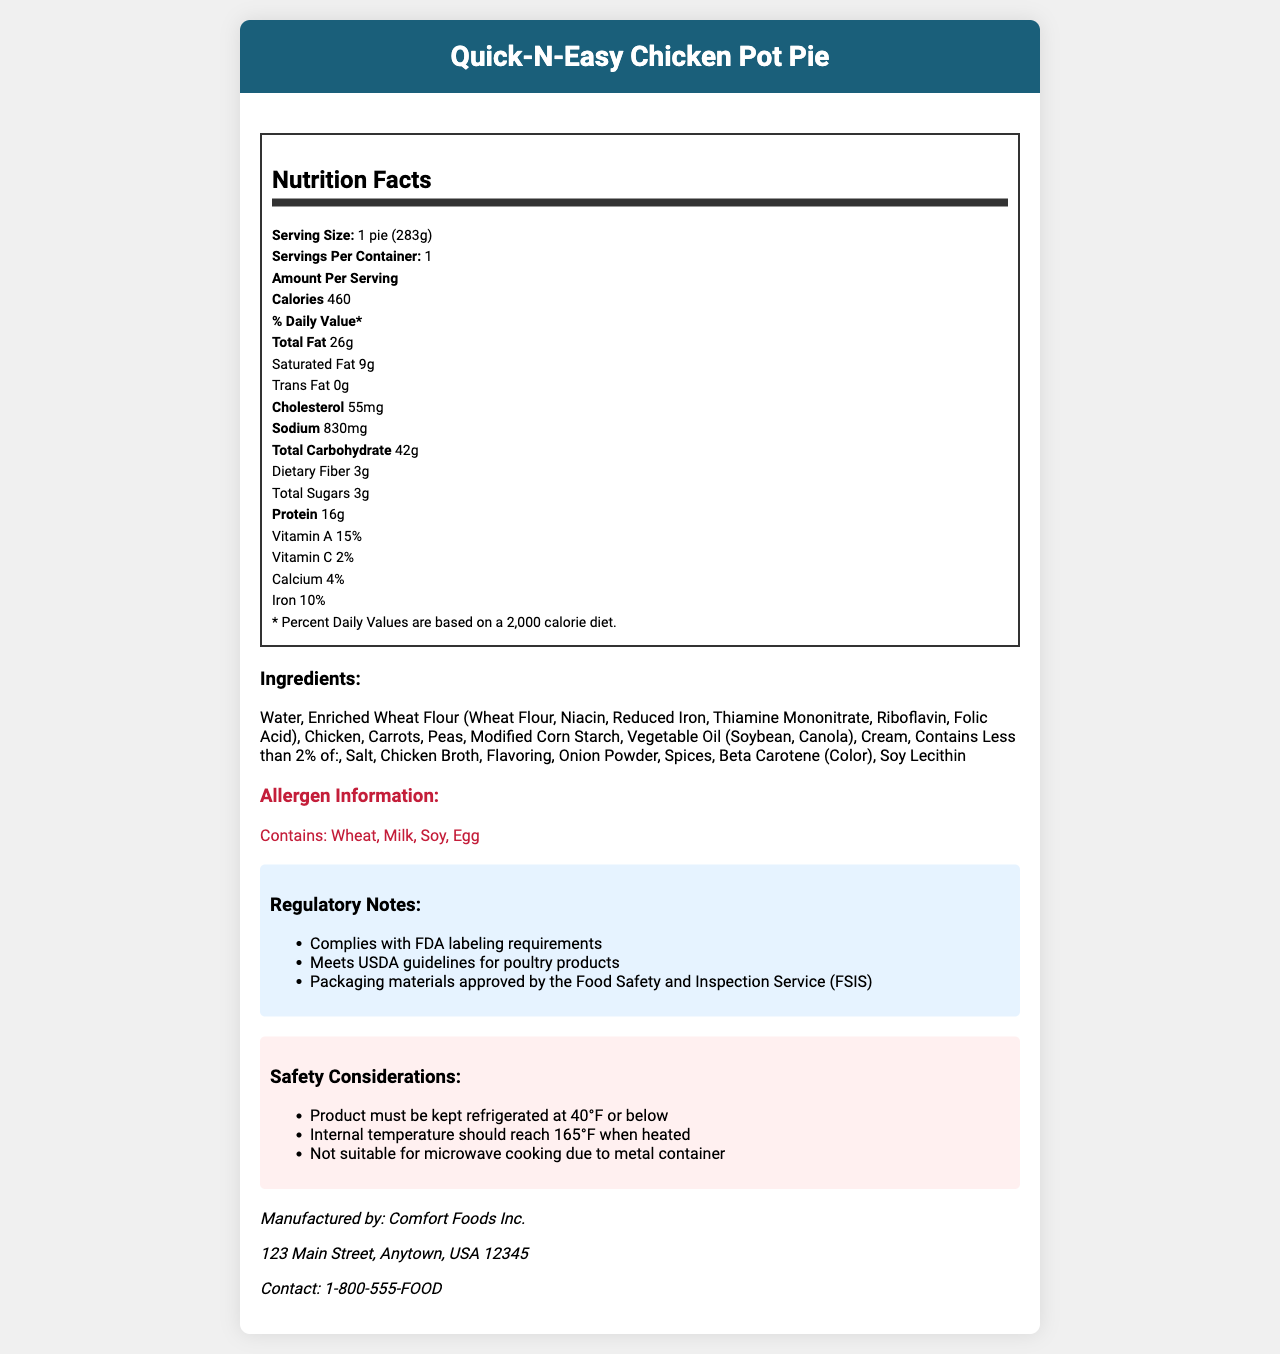what is the product name? The product name is displayed prominently in the header of the document.
Answer: Quick-N-Easy Chicken Pot Pie what is the serving size of the product? The serving size is stated under the Nutrition Facts section as "1 pie (283g)".
Answer: 1 pie (283g) how many allergens are listed and what are they? The allergen information section lists "Contains Wheat, Milk, Soy, Egg".
Answer: Four: Wheat, Milk, Soy, Egg what is the total fat content per serving? The total fat content is listed under the Nutrition Facts section as "Total Fat 26g".
Answer: 26g who is the manufacturer of the product? The manufacturer's name is provided in the Manufacturer Information section.
Answer: Comfort Foods Inc. what is the percentage of Vitamin A per serving? A. 10% B. 15% C. 20% The Nutrition Facts section states that the percentage of Vitamin A per serving is 15%.
Answer: B which ingredient is present in the smallest amount? A. Chicken B. Onion Powder C. Water D. Carrots The ingredient list mentions "Contains Less than 2% of: Salt, Chicken Broth, Flavoring, Onion Powder, Spices, Beta Carotene (Color), Soy Lecithin", indicating Onion Powder is in a minor quantity.
Answer: B is this product safe for people with soy allergies? The allergen information states that the product contains soy.
Answer: No does the product comply with USDA guidelines for poultry products? This information is included in the Regulatory Notes section which states, "Meets USDA guidelines for poultry products".
Answer: Yes summarize the main points regarding the product's regulatory and safety notes. The document lists these points under Regulatory Notes and Safety Considerations, detailing compliance and safety storage and cooking instructions.
Answer: The product complies with FDA labeling requirements and meets USDA guidelines for poultry products. Its packaging materials are approved by the FSIS. It must be kept refrigerated at 40°F or below, and its internal temperature should reach 165°F when heated. It is not suitable for microwave cooking due to the metal container. what is the internal heating temperature requirement for the product? The Safety Considerations section clarifies that the internal temperature should reach 165°F when heated.
Answer: 165°F does the product contain iron? If so, what is the percentage of the daily value? Under the Nutrition Facts, iron content per serving is listed as 10% of the daily value.
Answer: Yes, 10% is the product suitable for microwave cooking? The Safety Considerations section explicitly states it's not suitable for microwave cooking due to the metal container.
Answer: No what is the address of the manufacturer? The address is listed in the Manufacturer Information section.
Answer: 123 Main Street, Anytown, USA 12345 when was the last product recall? Under Recall History, it's stated that the last recall date is "None", and recall reason is "N/A".
Answer: Not applicable what are the five main ingredients in the product? The ingredient list starts with these items, indicating they are the main ingredients.
Answer: Water, Enriched Wheat Flour, Chicken, Carrots, Peas what kind of diet is the labeled percent daily value based on? The Nutrition Facts section explains that Percent Daily Values are based on a 2,000 calorie diet.
Answer: 2,000 calorie diet what is the total carbohydrate content and dietary fiber content per serving? The Nutrition Facts section lists total carbohydrate as 42g and dietary fiber as 3g per serving.
Answer: Total Carbohydrate: 42g, Dietary Fiber: 3g which type of oil is used in the product? The ingredient list specifies that vegetable oil in the product consists of soybean and canola oils.
Answer: Vegetable Oil (Soybean, Canola) what is the contact information for the manufacturer? This information is provided in the Manufacturer Information section.
Answer: 1-800-555-FOOD describe the entire document. The document provides comprehensive details about the product to inform consumers and regulators.
Answer: The document is a Nutrition Facts Label for Quick-N-Easy Chicken Pot Pie. It includes detailed nutritional facts, allergen information, an ingredient list, regulatory notes, safety considerations, manufacturer details, recall history, transportation requirements, and shelf life. Key points include serving size, nutrient content, allergens, cooking and storage instructions, and contact and location for the manufacturer. is the source code used to generate the document available? The document does not mention anything about the source code used to generate it.
Answer: Not enough information 